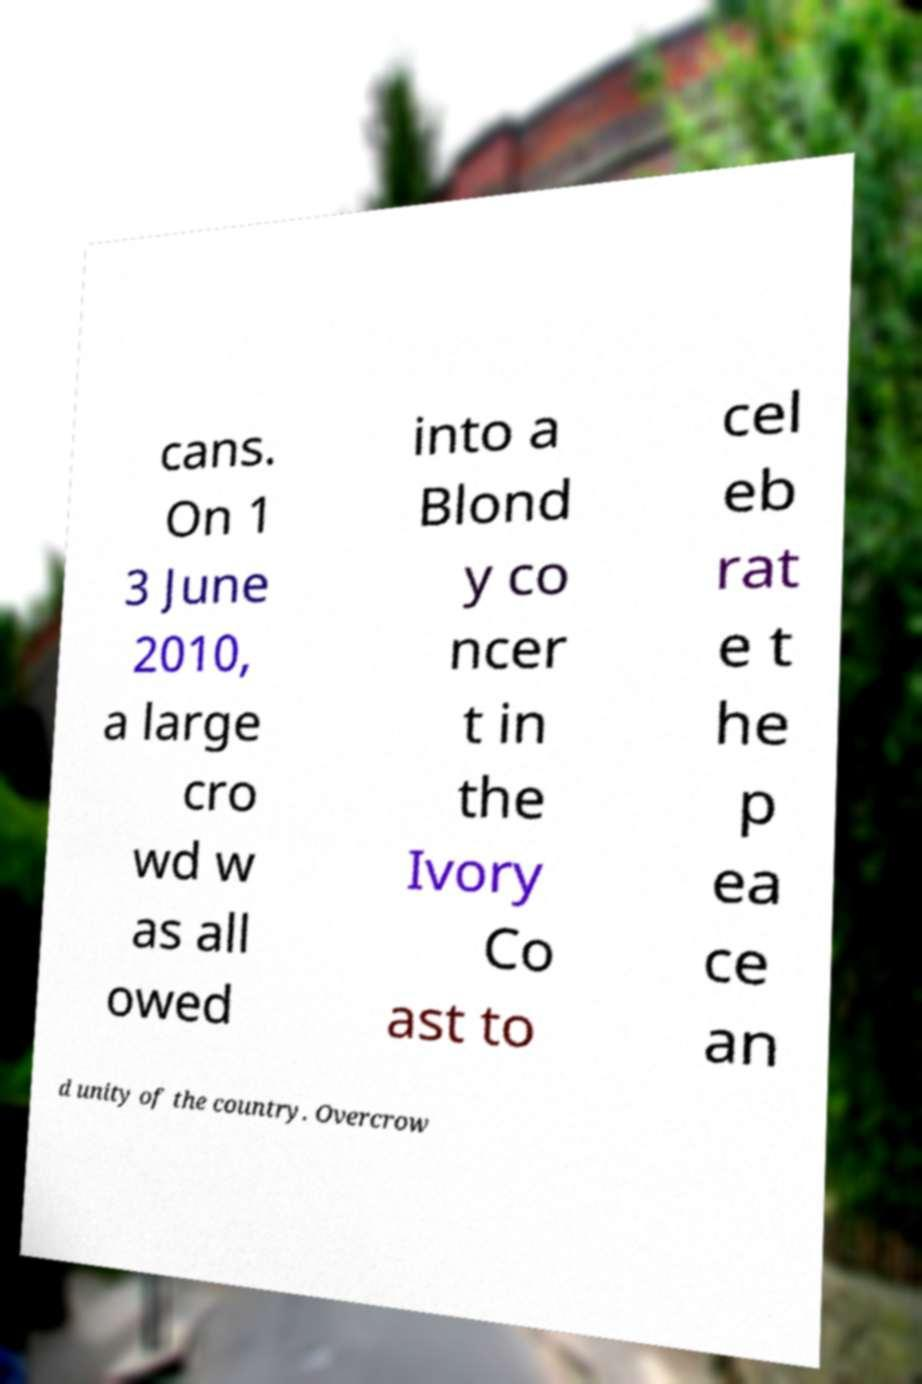Please read and relay the text visible in this image. What does it say? cans. On 1 3 June 2010, a large cro wd w as all owed into a Blond y co ncer t in the Ivory Co ast to cel eb rat e t he p ea ce an d unity of the country. Overcrow 